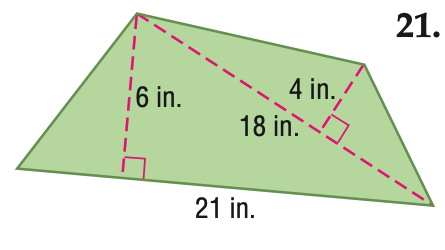Answer the mathemtical geometry problem and directly provide the correct option letter.
Question: Find the area of the figure. Round to the nearest tenth if necessary.
Choices: A: 72 B: 99 C: 126 D: 198 B 